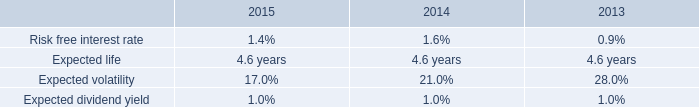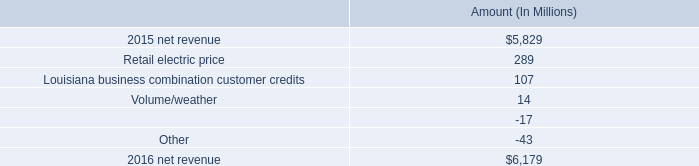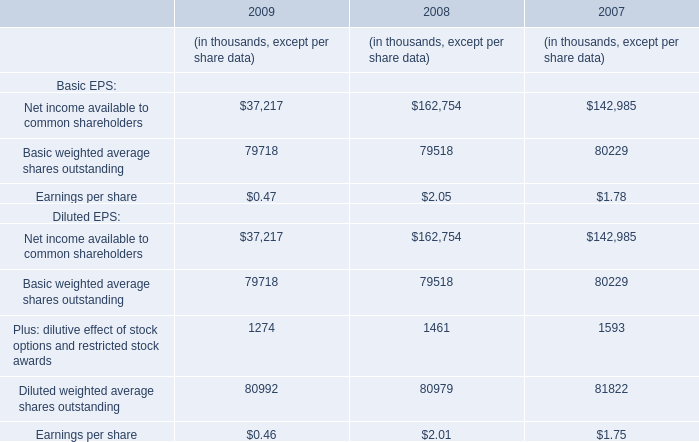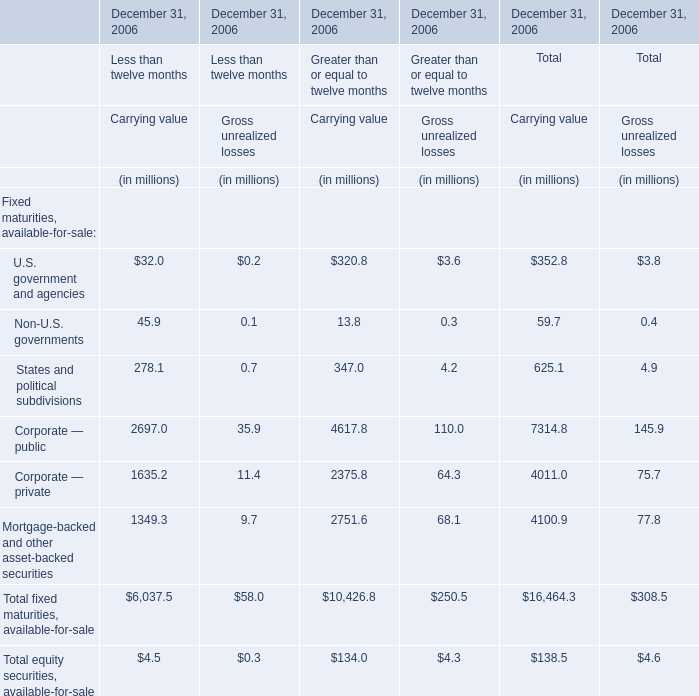what portion of the net change in net revenue during 2016 is related to the change in retail electric price? 
Computations: (289 / (6179 - 5829))
Answer: 0.82571. 